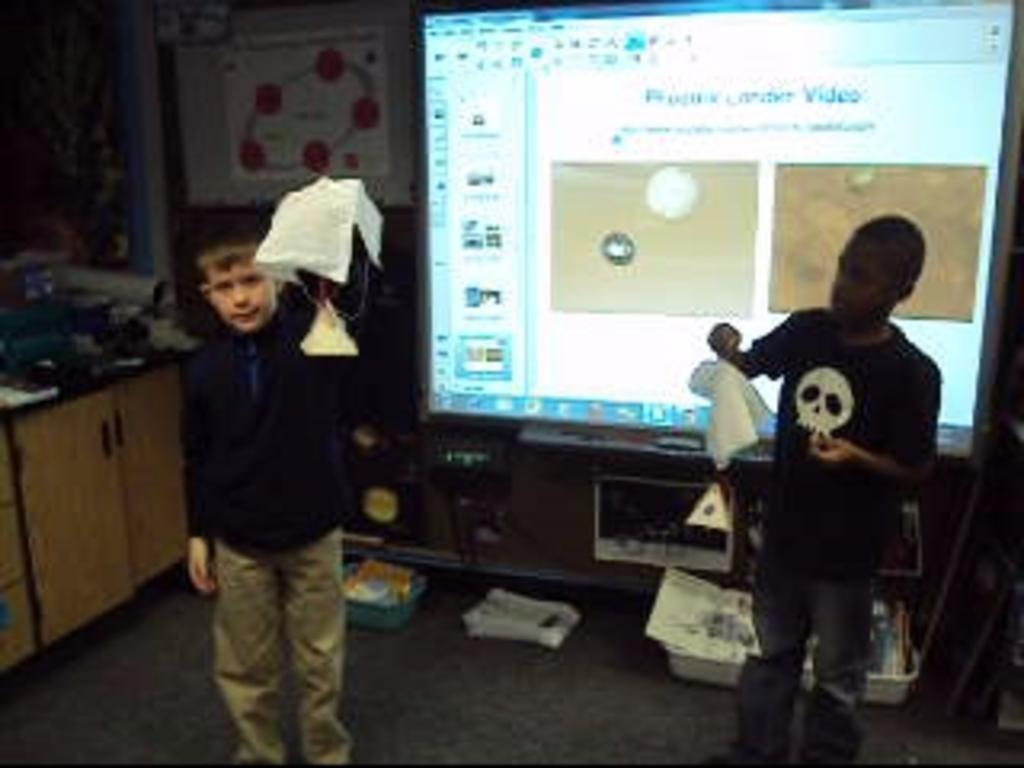How many people are in the image? There are two persons in the image. What are the persons holding in the image? The persons are holding napkins. What can be seen in the background of the image? There is a screen visible in the image. Where is the cupboard located in the image? The cupboard is on the left side of the image. What is the general setting of the image? The persons are surrounded by objects. What type of boat can be seen in the image? There is no boat present in the image. How do the persons react to the shirt in the image? There is no shirt mentioned in the image, so it is not possible to determine any reactions to it. 